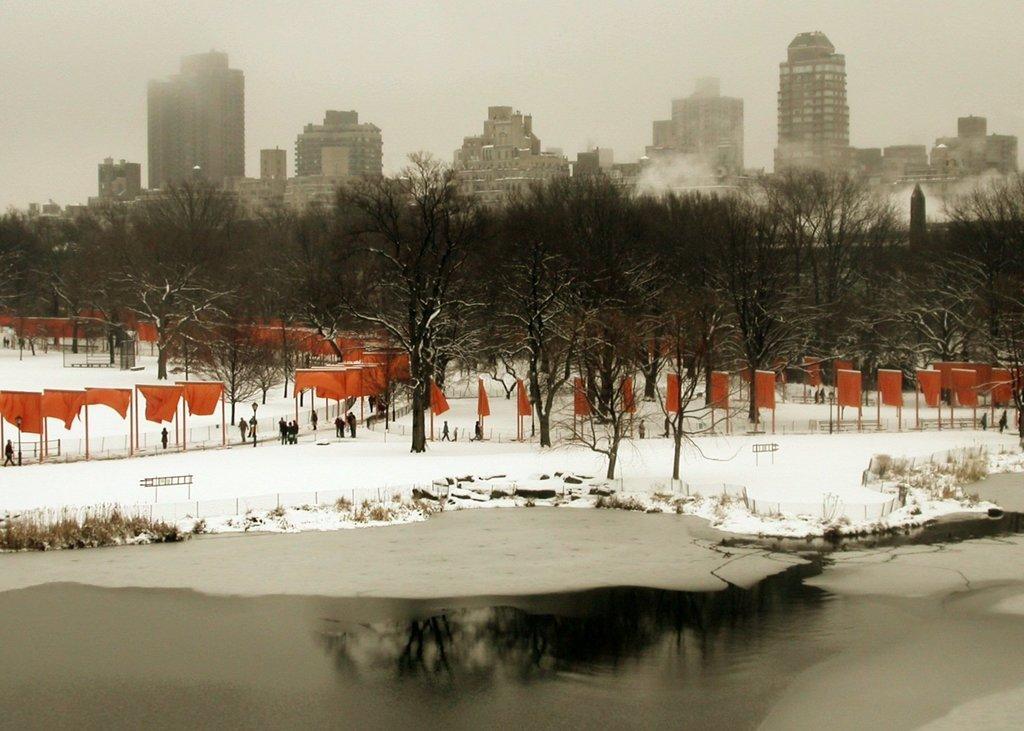Describe this image in one or two sentences. In this image I see the water in front, snow over here, lot of trees, flags and few people. In the background I can see lot of buildings. 